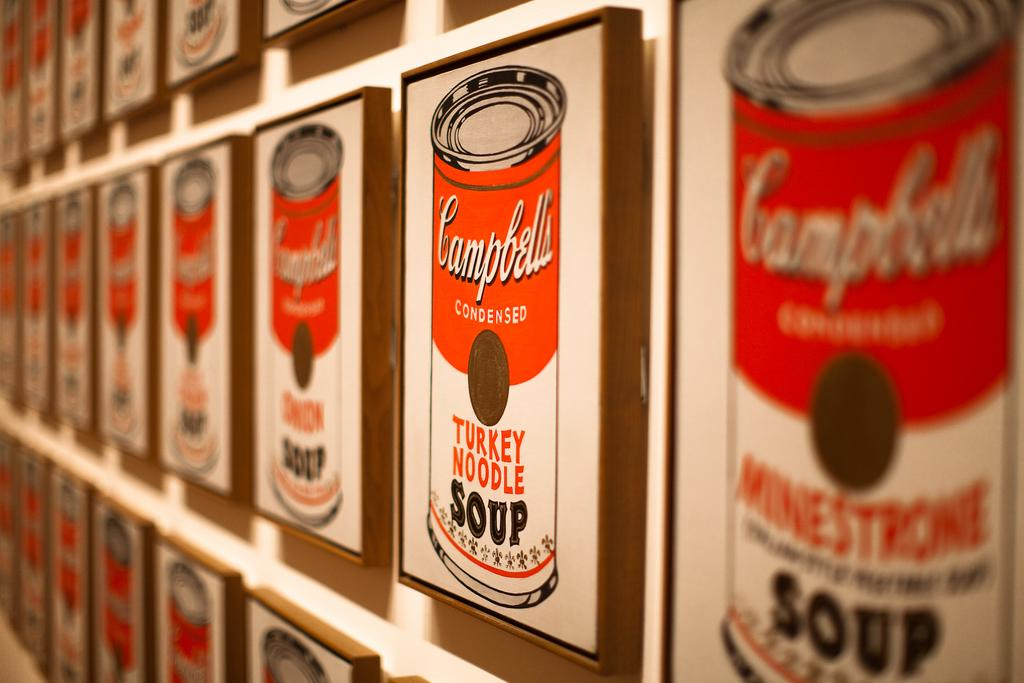<image>
Render a clear and concise summary of the photo. Different kinds of Campell's soup on pictures hanging up. 